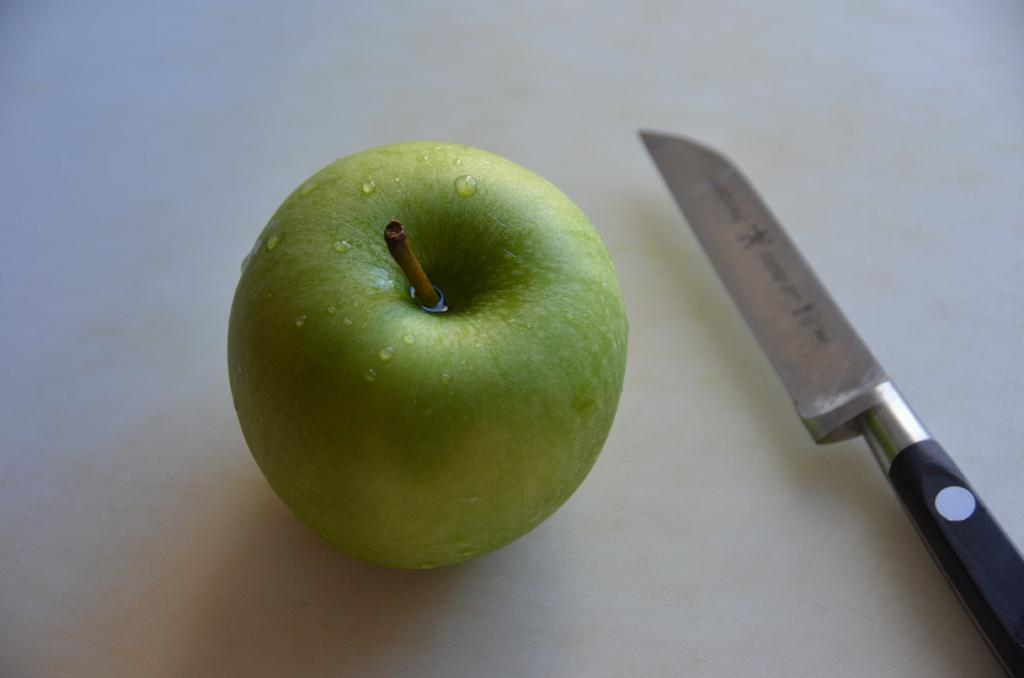Please provide a concise description of this image. In this image we have a green apple and a knife. 